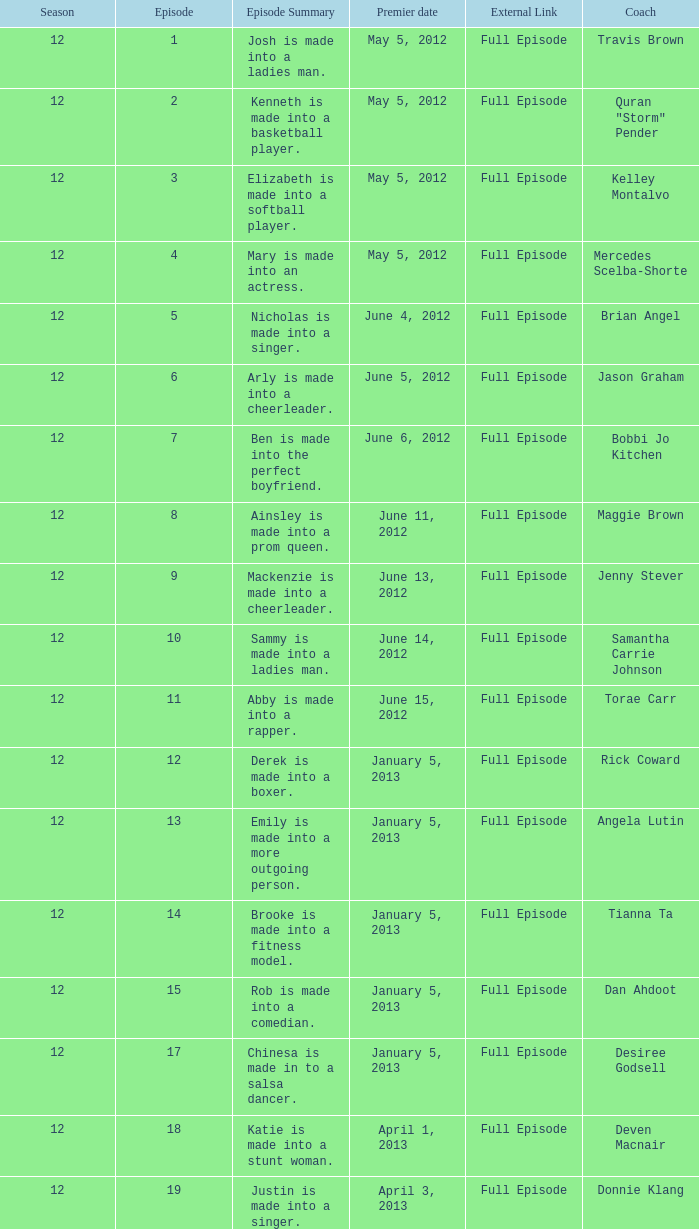Name the episode summary for travis brown Josh is made into a ladies man. 